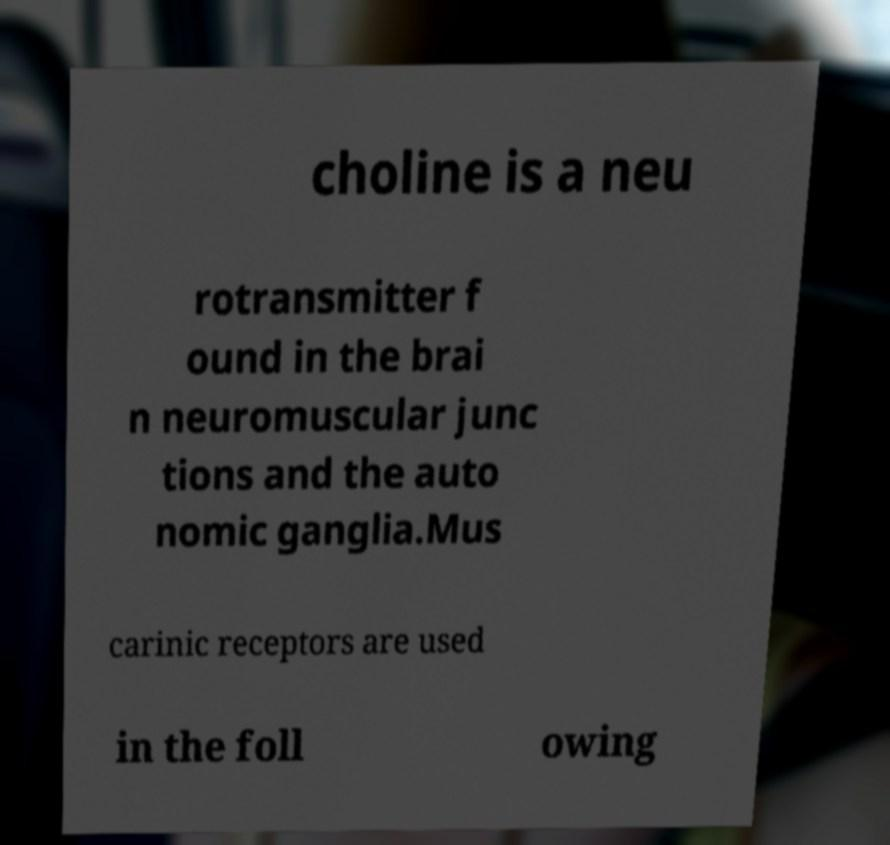Please read and relay the text visible in this image. What does it say? choline is a neu rotransmitter f ound in the brai n neuromuscular junc tions and the auto nomic ganglia.Mus carinic receptors are used in the foll owing 